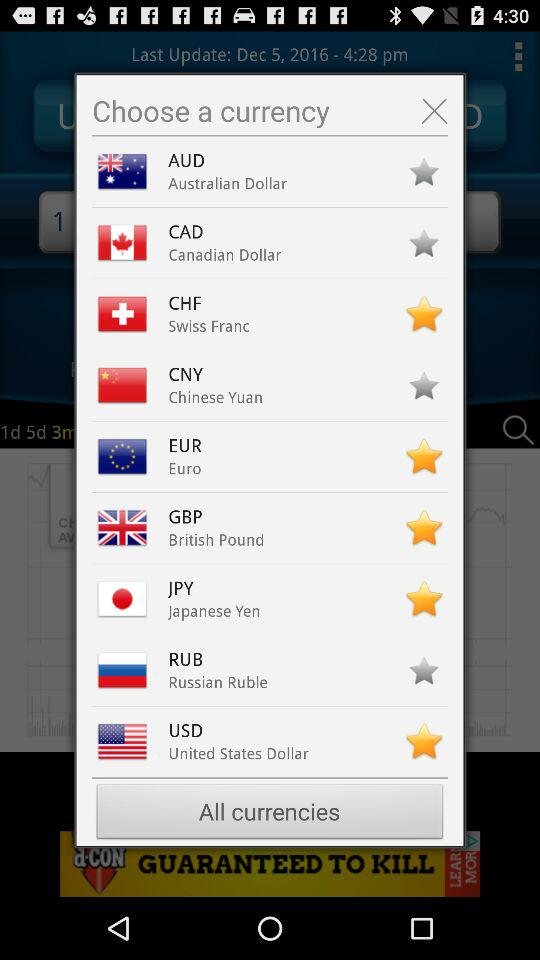In which time zone was the last update?
When the provided information is insufficient, respond with <no answer>. <no answer> 